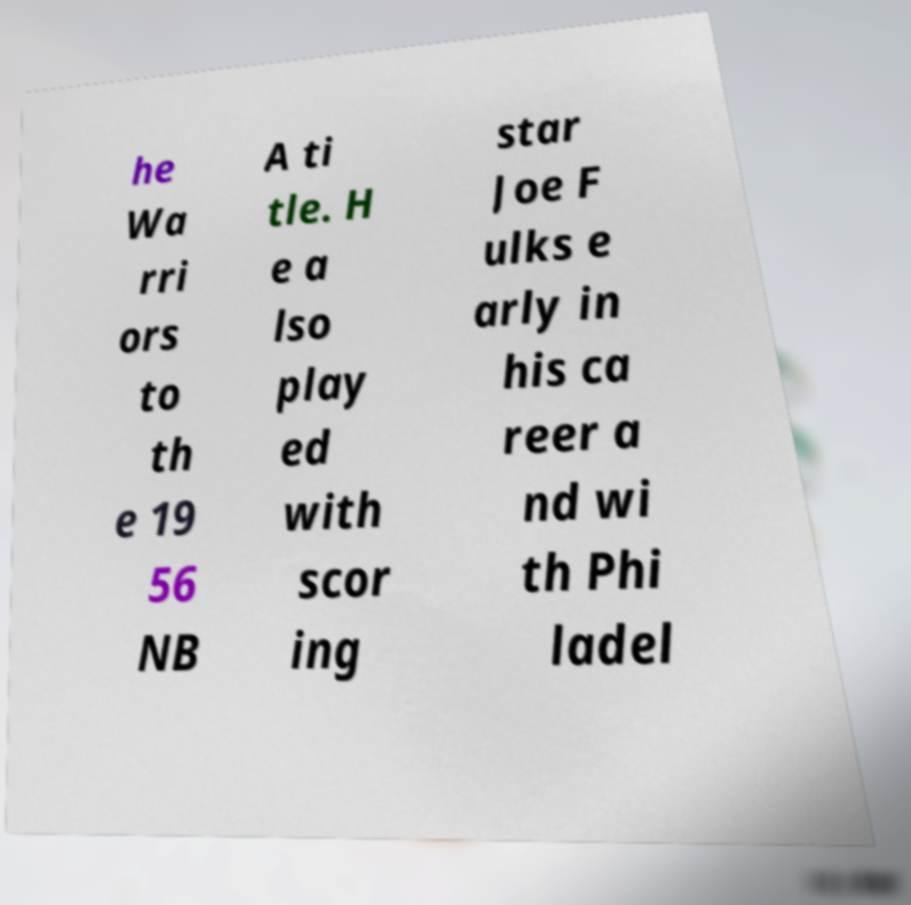What messages or text are displayed in this image? I need them in a readable, typed format. he Wa rri ors to th e 19 56 NB A ti tle. H e a lso play ed with scor ing star Joe F ulks e arly in his ca reer a nd wi th Phi ladel 